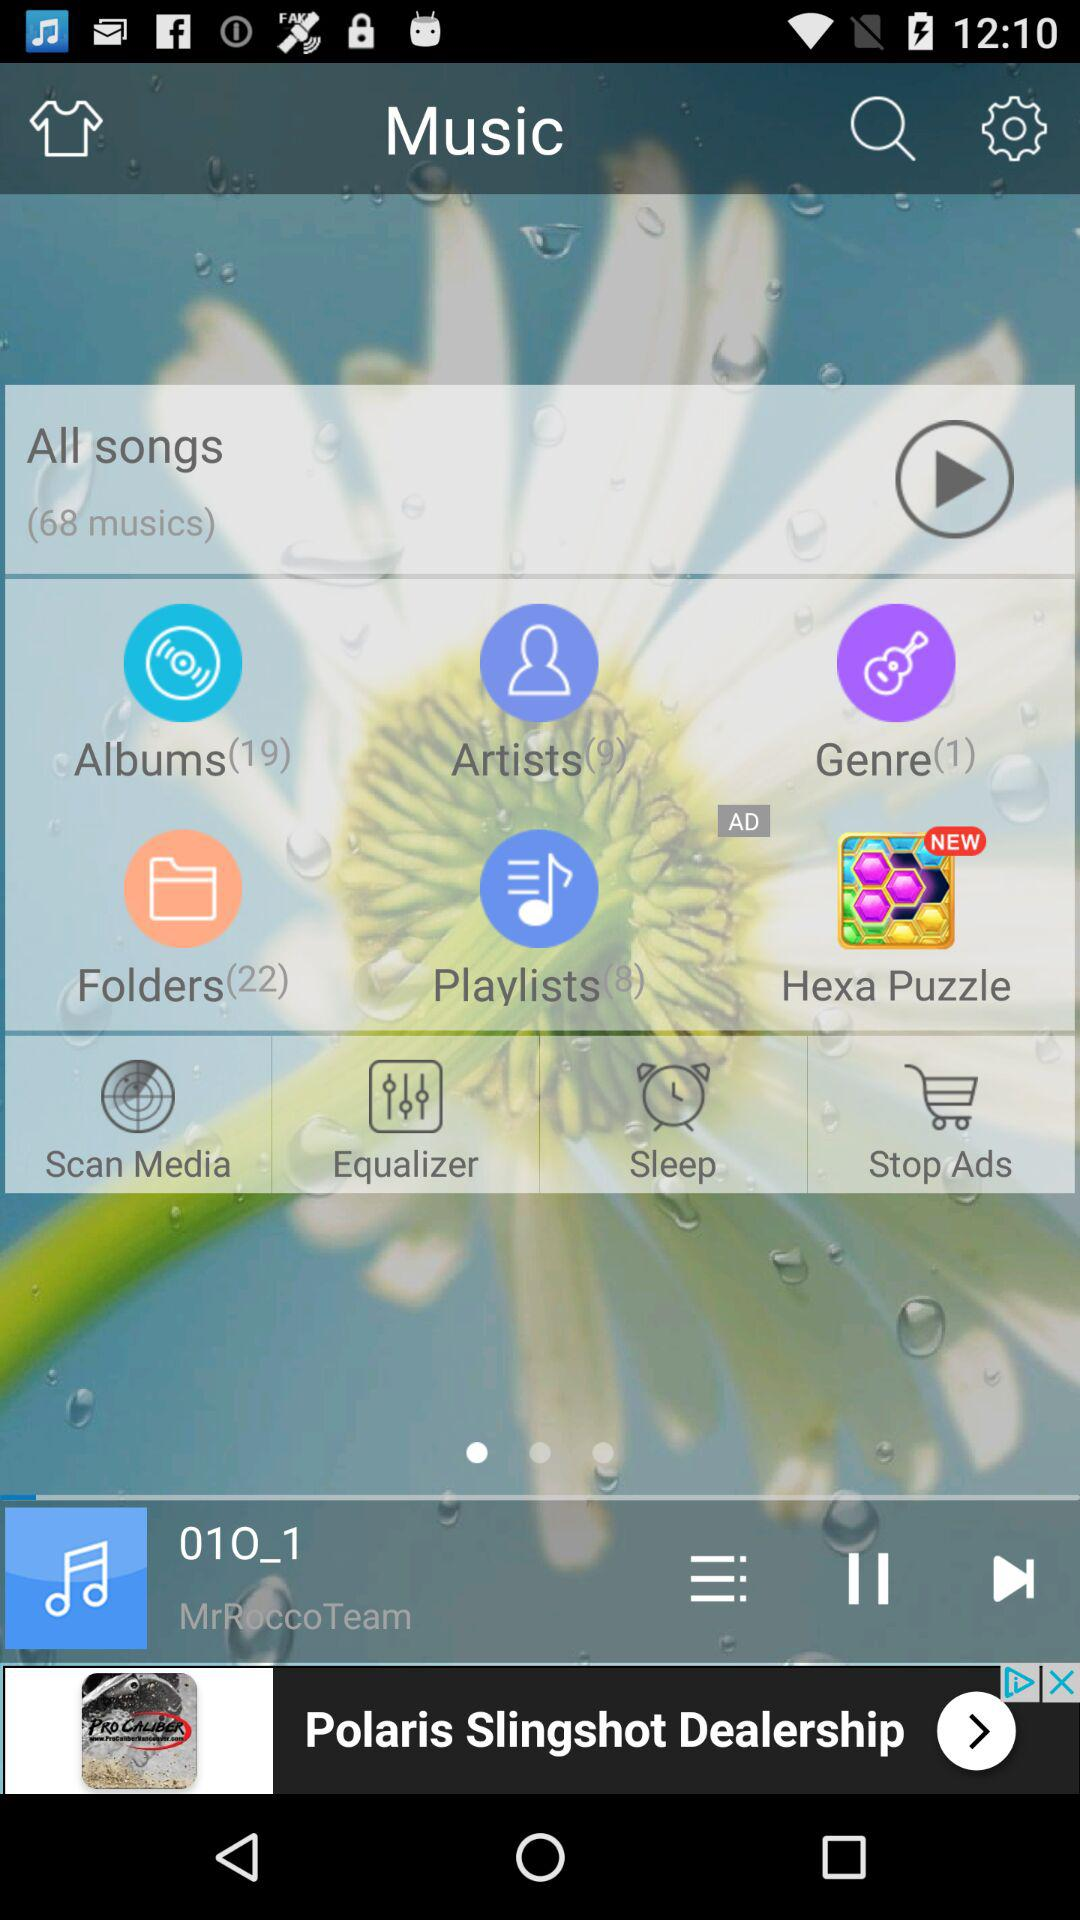What is the name of the singer of the song that is currently playing? The name of the singer is "MrRoccoTeam". 